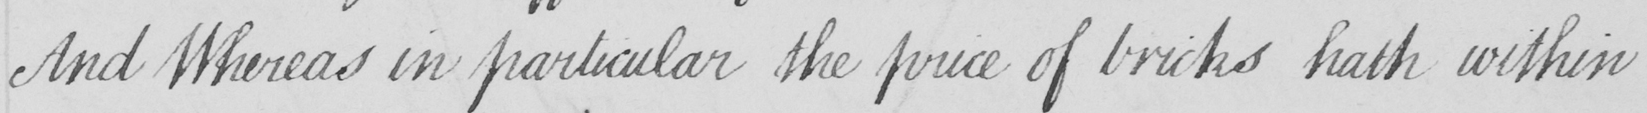Can you read and transcribe this handwriting? And Whereas in particular the price of bricks hath within 